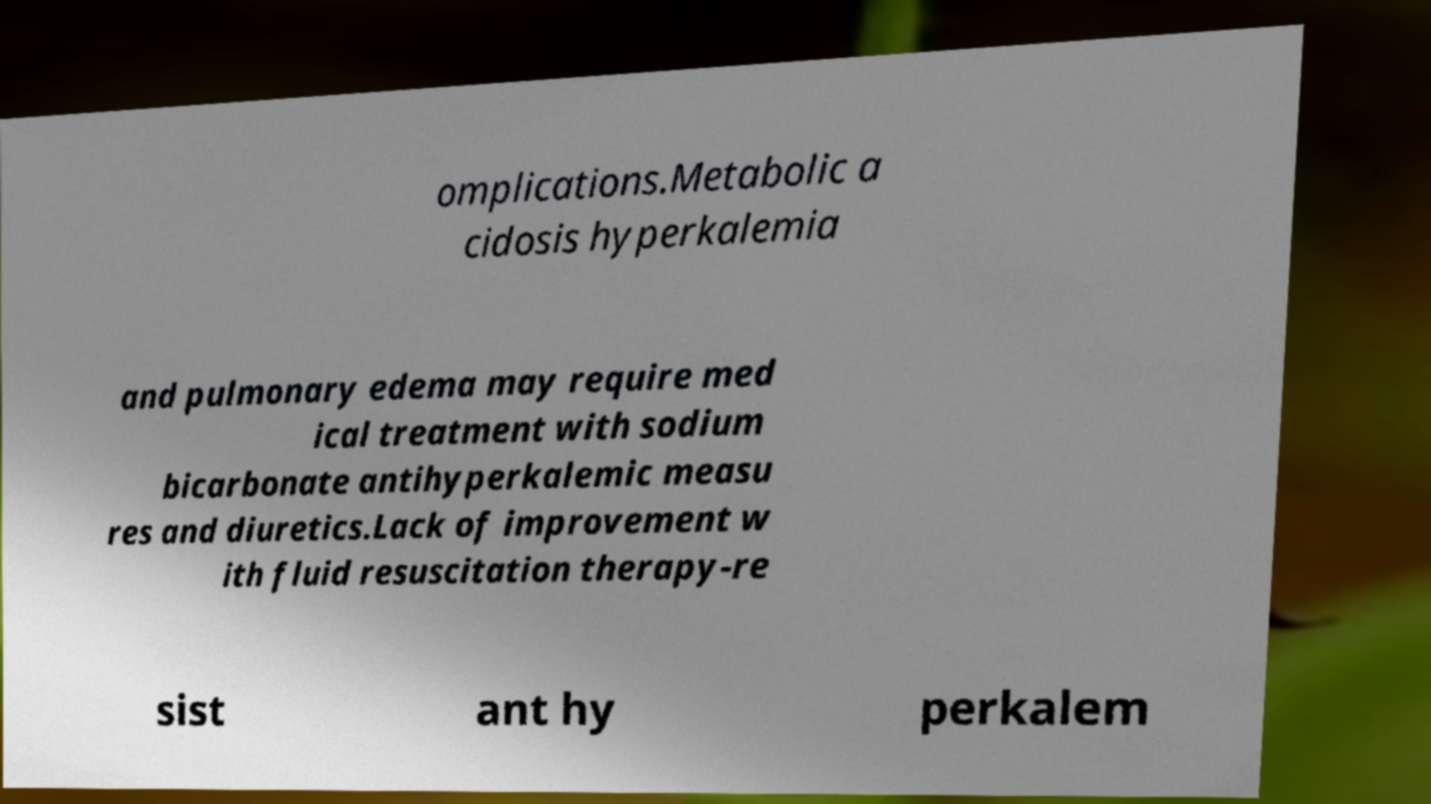Can you accurately transcribe the text from the provided image for me? omplications.Metabolic a cidosis hyperkalemia and pulmonary edema may require med ical treatment with sodium bicarbonate antihyperkalemic measu res and diuretics.Lack of improvement w ith fluid resuscitation therapy-re sist ant hy perkalem 